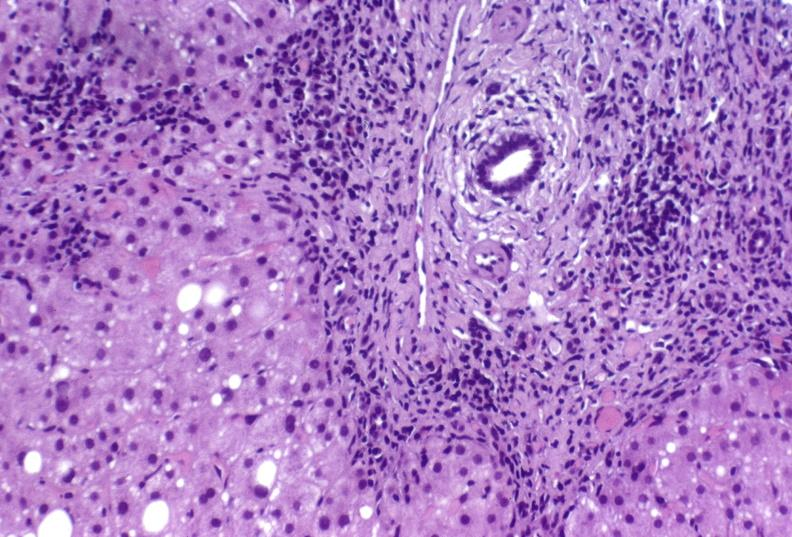what is present?
Answer the question using a single word or phrase. Hepatobiliary 